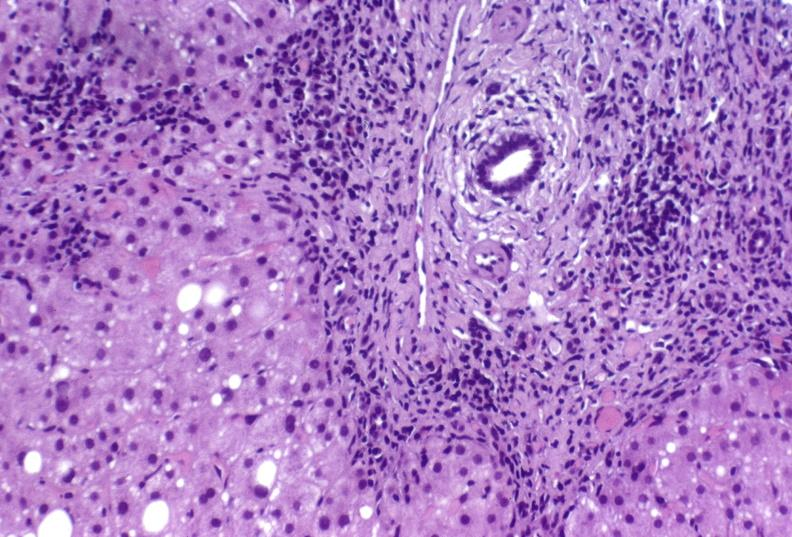what is present?
Answer the question using a single word or phrase. Hepatobiliary 